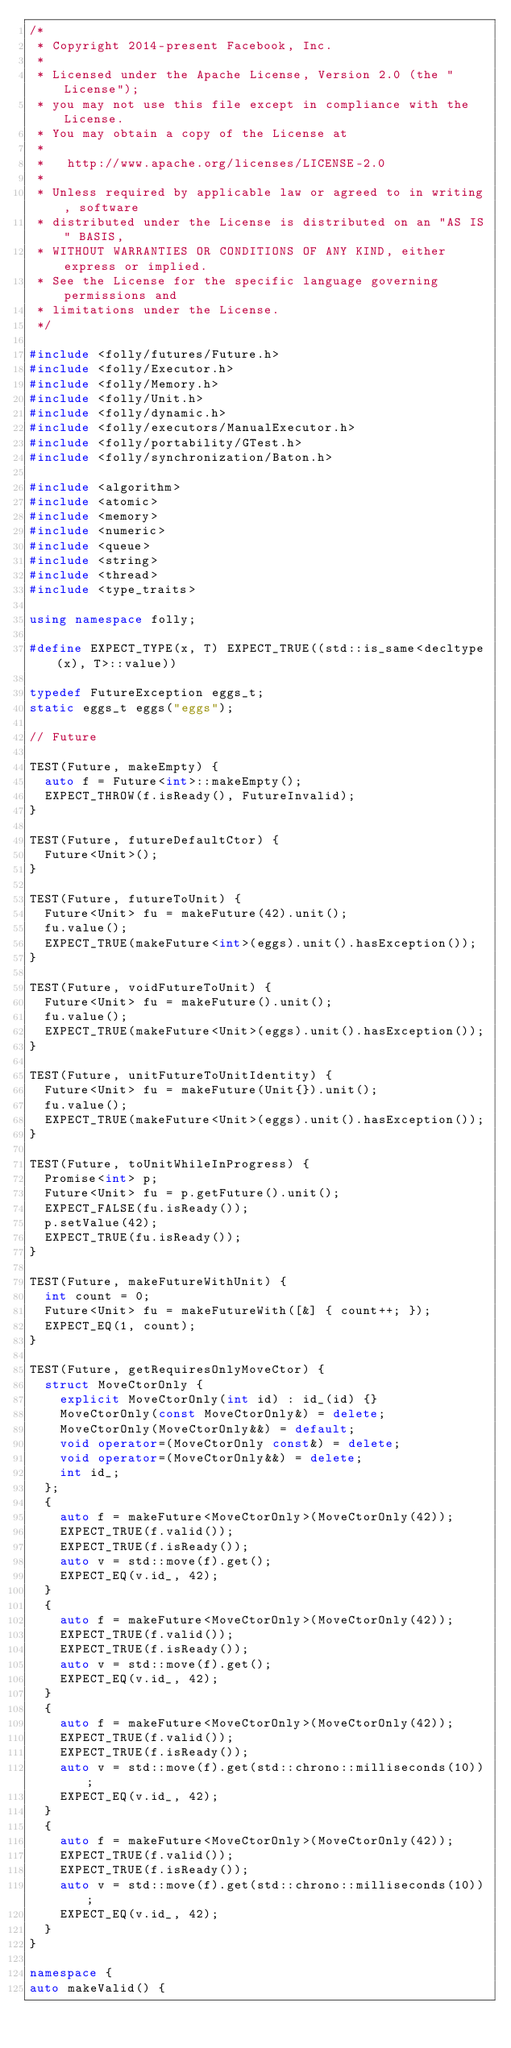Convert code to text. <code><loc_0><loc_0><loc_500><loc_500><_C++_>/*
 * Copyright 2014-present Facebook, Inc.
 *
 * Licensed under the Apache License, Version 2.0 (the "License");
 * you may not use this file except in compliance with the License.
 * You may obtain a copy of the License at
 *
 *   http://www.apache.org/licenses/LICENSE-2.0
 *
 * Unless required by applicable law or agreed to in writing, software
 * distributed under the License is distributed on an "AS IS" BASIS,
 * WITHOUT WARRANTIES OR CONDITIONS OF ANY KIND, either express or implied.
 * See the License for the specific language governing permissions and
 * limitations under the License.
 */

#include <folly/futures/Future.h>
#include <folly/Executor.h>
#include <folly/Memory.h>
#include <folly/Unit.h>
#include <folly/dynamic.h>
#include <folly/executors/ManualExecutor.h>
#include <folly/portability/GTest.h>
#include <folly/synchronization/Baton.h>

#include <algorithm>
#include <atomic>
#include <memory>
#include <numeric>
#include <queue>
#include <string>
#include <thread>
#include <type_traits>

using namespace folly;

#define EXPECT_TYPE(x, T) EXPECT_TRUE((std::is_same<decltype(x), T>::value))

typedef FutureException eggs_t;
static eggs_t eggs("eggs");

// Future

TEST(Future, makeEmpty) {
  auto f = Future<int>::makeEmpty();
  EXPECT_THROW(f.isReady(), FutureInvalid);
}

TEST(Future, futureDefaultCtor) {
  Future<Unit>();
}

TEST(Future, futureToUnit) {
  Future<Unit> fu = makeFuture(42).unit();
  fu.value();
  EXPECT_TRUE(makeFuture<int>(eggs).unit().hasException());
}

TEST(Future, voidFutureToUnit) {
  Future<Unit> fu = makeFuture().unit();
  fu.value();
  EXPECT_TRUE(makeFuture<Unit>(eggs).unit().hasException());
}

TEST(Future, unitFutureToUnitIdentity) {
  Future<Unit> fu = makeFuture(Unit{}).unit();
  fu.value();
  EXPECT_TRUE(makeFuture<Unit>(eggs).unit().hasException());
}

TEST(Future, toUnitWhileInProgress) {
  Promise<int> p;
  Future<Unit> fu = p.getFuture().unit();
  EXPECT_FALSE(fu.isReady());
  p.setValue(42);
  EXPECT_TRUE(fu.isReady());
}

TEST(Future, makeFutureWithUnit) {
  int count = 0;
  Future<Unit> fu = makeFutureWith([&] { count++; });
  EXPECT_EQ(1, count);
}

TEST(Future, getRequiresOnlyMoveCtor) {
  struct MoveCtorOnly {
    explicit MoveCtorOnly(int id) : id_(id) {}
    MoveCtorOnly(const MoveCtorOnly&) = delete;
    MoveCtorOnly(MoveCtorOnly&&) = default;
    void operator=(MoveCtorOnly const&) = delete;
    void operator=(MoveCtorOnly&&) = delete;
    int id_;
  };
  {
    auto f = makeFuture<MoveCtorOnly>(MoveCtorOnly(42));
    EXPECT_TRUE(f.valid());
    EXPECT_TRUE(f.isReady());
    auto v = std::move(f).get();
    EXPECT_EQ(v.id_, 42);
  }
  {
    auto f = makeFuture<MoveCtorOnly>(MoveCtorOnly(42));
    EXPECT_TRUE(f.valid());
    EXPECT_TRUE(f.isReady());
    auto v = std::move(f).get();
    EXPECT_EQ(v.id_, 42);
  }
  {
    auto f = makeFuture<MoveCtorOnly>(MoveCtorOnly(42));
    EXPECT_TRUE(f.valid());
    EXPECT_TRUE(f.isReady());
    auto v = std::move(f).get(std::chrono::milliseconds(10));
    EXPECT_EQ(v.id_, 42);
  }
  {
    auto f = makeFuture<MoveCtorOnly>(MoveCtorOnly(42));
    EXPECT_TRUE(f.valid());
    EXPECT_TRUE(f.isReady());
    auto v = std::move(f).get(std::chrono::milliseconds(10));
    EXPECT_EQ(v.id_, 42);
  }
}

namespace {
auto makeValid() {</code> 